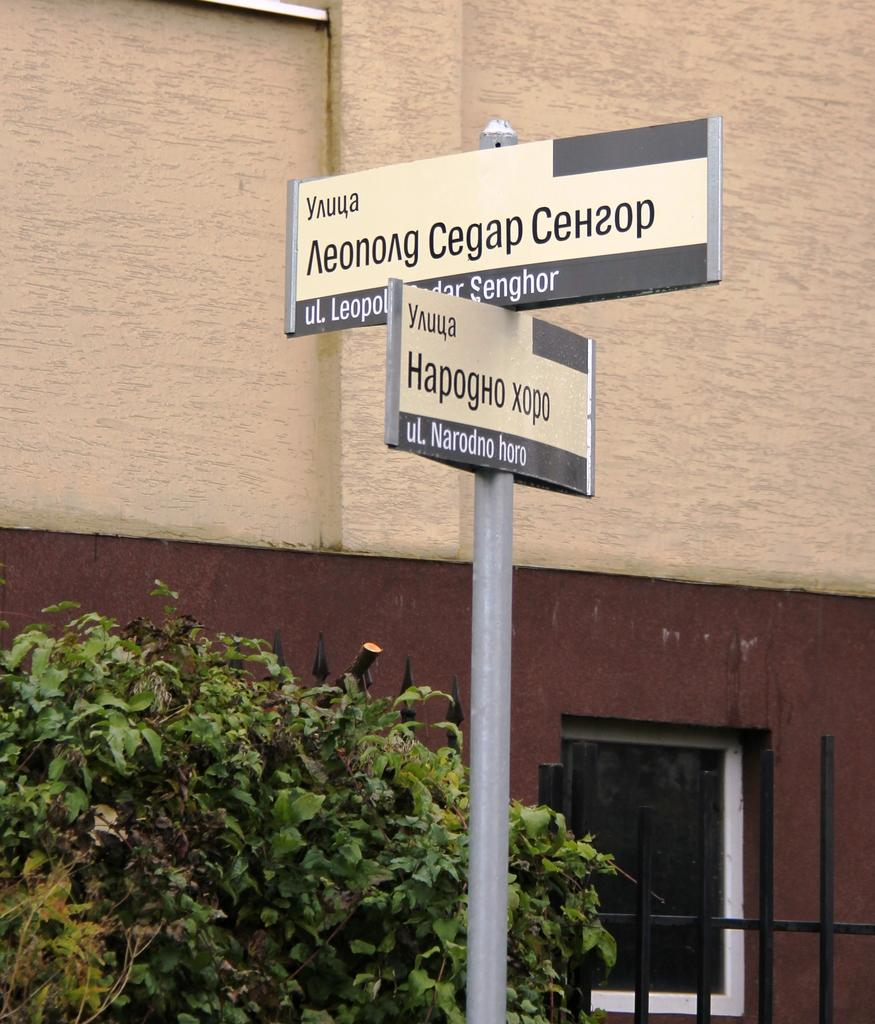What is the main object in the image? There is a name board in the image. What is located near the name board? There is a plant beside the name board. What type of structure can be seen in the image? There is a fence in the image. What can be seen in the background of the image? There is a building in the background of the image. How many cats are playing with the waves in the image? There are no cats or waves present in the image. What type of beam is holding up the building in the image? There is no beam visible in the image, and the type of support for the building cannot be determined. 